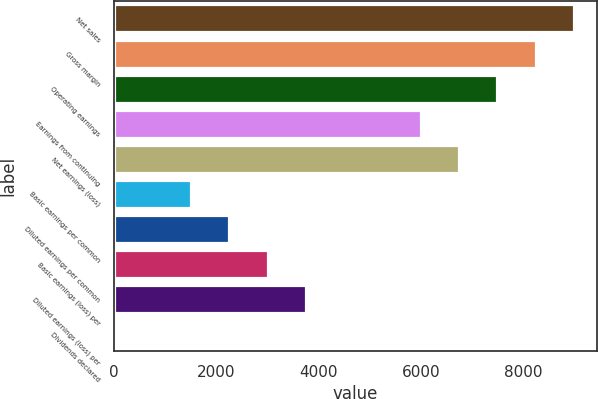Convert chart. <chart><loc_0><loc_0><loc_500><loc_500><bar_chart><fcel>Net sales<fcel>Gross margin<fcel>Operating earnings<fcel>Earnings from continuing<fcel>Net earnings (loss)<fcel>Basic earnings per common<fcel>Diluted earnings per common<fcel>Basic earnings (loss) per<fcel>Diluted earnings (loss) per<fcel>Dividends declared<nl><fcel>8998.84<fcel>8248.94<fcel>7499.04<fcel>5999.24<fcel>6749.14<fcel>1499.84<fcel>2249.74<fcel>2999.64<fcel>3749.54<fcel>0.04<nl></chart> 